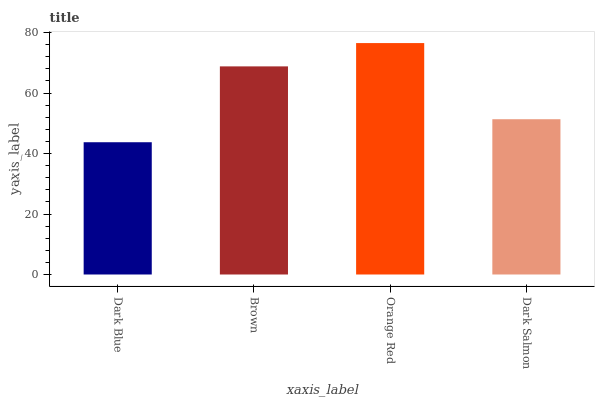Is Dark Blue the minimum?
Answer yes or no. Yes. Is Orange Red the maximum?
Answer yes or no. Yes. Is Brown the minimum?
Answer yes or no. No. Is Brown the maximum?
Answer yes or no. No. Is Brown greater than Dark Blue?
Answer yes or no. Yes. Is Dark Blue less than Brown?
Answer yes or no. Yes. Is Dark Blue greater than Brown?
Answer yes or no. No. Is Brown less than Dark Blue?
Answer yes or no. No. Is Brown the high median?
Answer yes or no. Yes. Is Dark Salmon the low median?
Answer yes or no. Yes. Is Dark Salmon the high median?
Answer yes or no. No. Is Brown the low median?
Answer yes or no. No. 